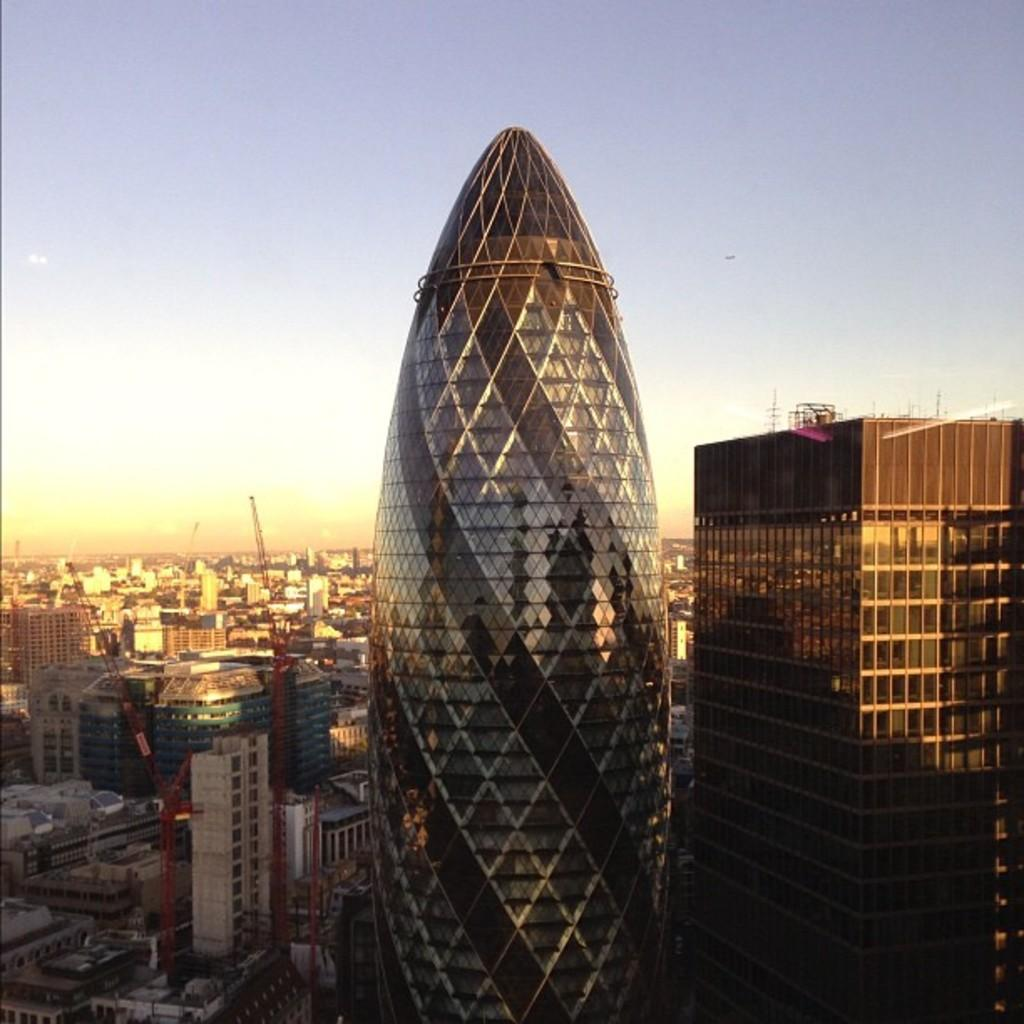What is the main subject of the image? The main subject of the image is many buildings. What can be seen to the left of the buildings? There are cranes visible to the left. What is visible in the background of the image? The sky is visible in the background of the image. How many rings were discovered during the construction process in the image? There is no mention of rings or any discovery process in the image; it primarily features buildings and cranes. 